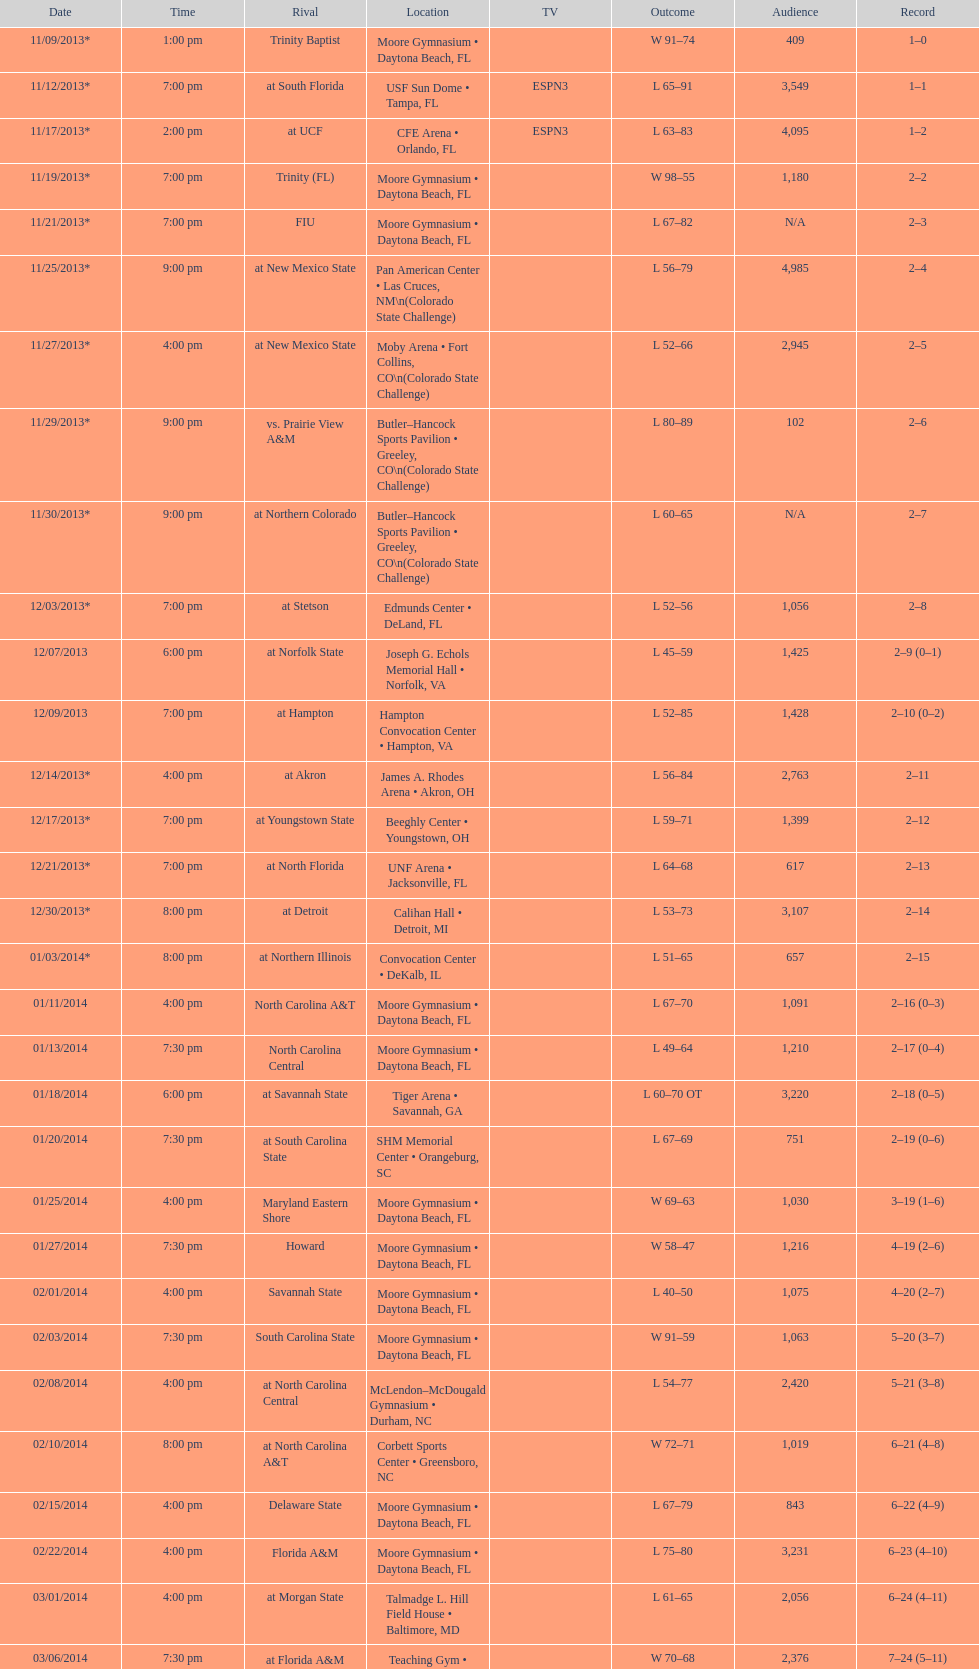Which game was later at night, fiu or northern colorado? Northern Colorado. 